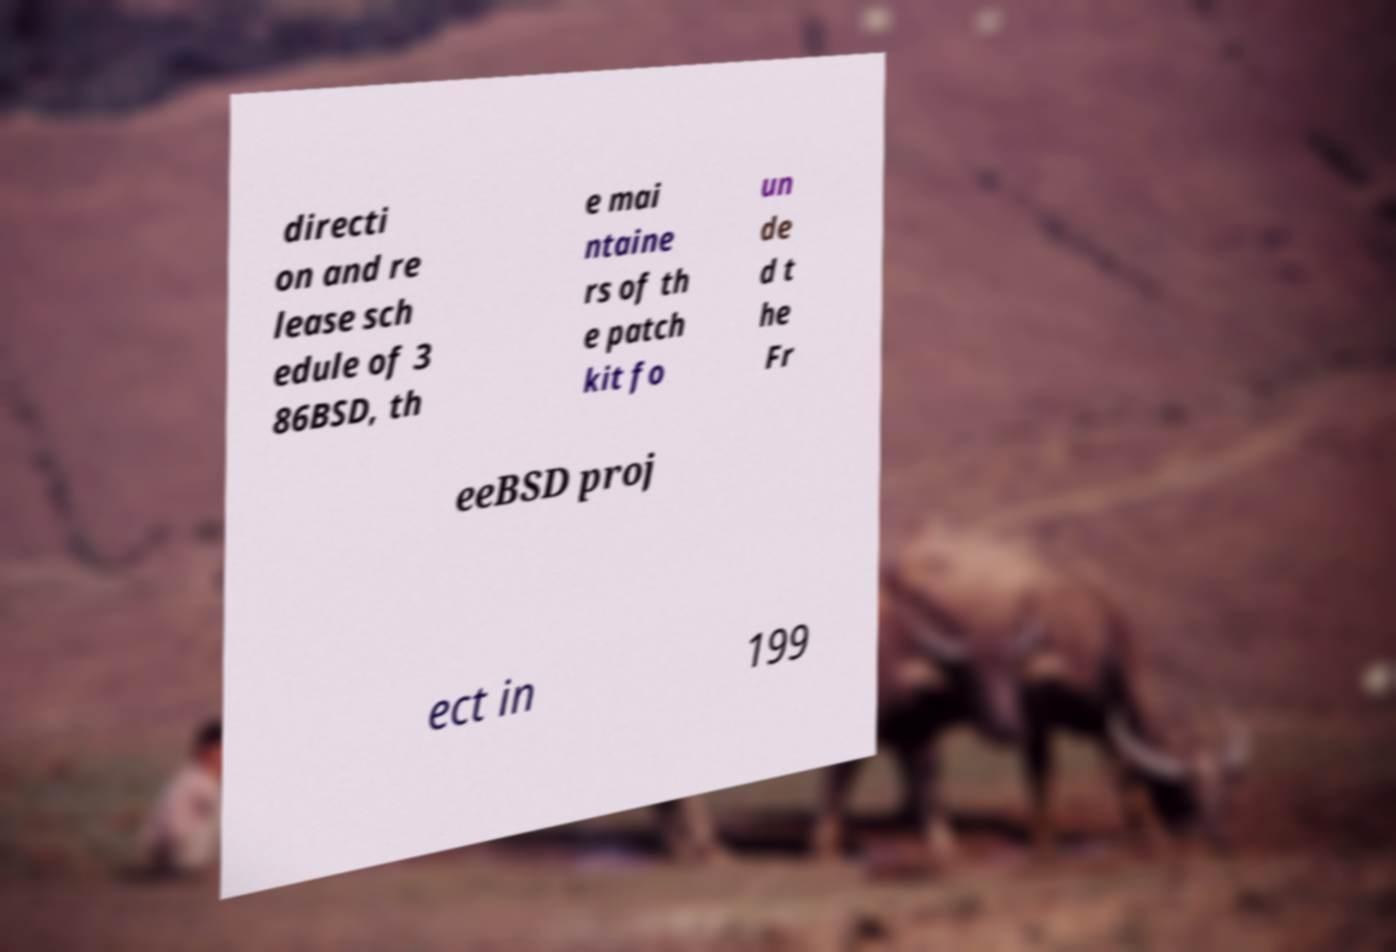There's text embedded in this image that I need extracted. Can you transcribe it verbatim? directi on and re lease sch edule of 3 86BSD, th e mai ntaine rs of th e patch kit fo un de d t he Fr eeBSD proj ect in 199 